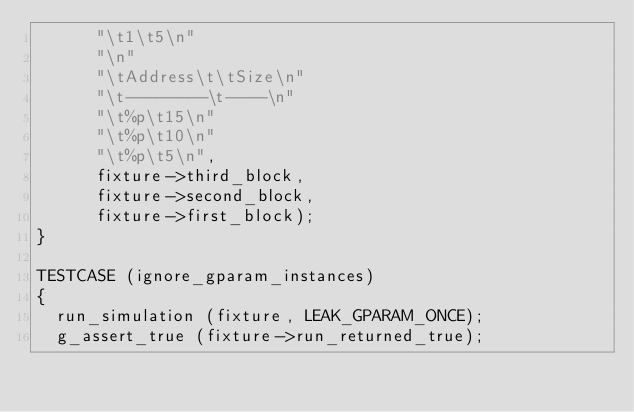Convert code to text. <code><loc_0><loc_0><loc_500><loc_500><_C_>      "\t1\t5\n"
      "\n"
      "\tAddress\t\tSize\n"
      "\t--------\t----\n"
      "\t%p\t15\n"
      "\t%p\t10\n"
      "\t%p\t5\n",
      fixture->third_block,
      fixture->second_block,
      fixture->first_block);
}

TESTCASE (ignore_gparam_instances)
{
  run_simulation (fixture, LEAK_GPARAM_ONCE);
  g_assert_true (fixture->run_returned_true);</code> 